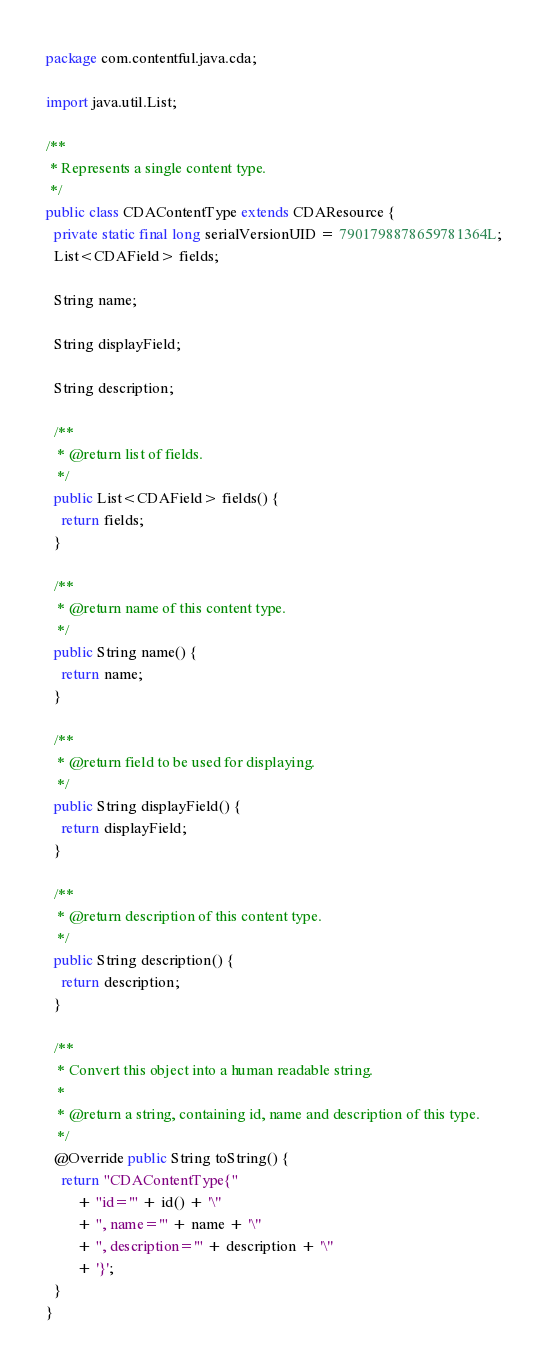Convert code to text. <code><loc_0><loc_0><loc_500><loc_500><_Java_>package com.contentful.java.cda;

import java.util.List;

/**
 * Represents a single content type.
 */
public class CDAContentType extends CDAResource {
  private static final long serialVersionUID = 7901798878659781364L;
  List<CDAField> fields;

  String name;

  String displayField;

  String description;

  /**
   * @return list of fields.
   */
  public List<CDAField> fields() {
    return fields;
  }

  /**
   * @return name of this content type.
   */
  public String name() {
    return name;
  }

  /**
   * @return field to be used for displaying.
   */
  public String displayField() {
    return displayField;
  }

  /**
   * @return description of this content type.
   */
  public String description() {
    return description;
  }

  /**
   * Convert this object into a human readable string.
   *
   * @return a string, containing id, name and description of this type.
   */
  @Override public String toString() {
    return "CDAContentType{"
        + "id='" + id() + '\''
        + ", name='" + name + '\''
        + ", description='" + description + '\''
        + '}';
  }
}
</code> 